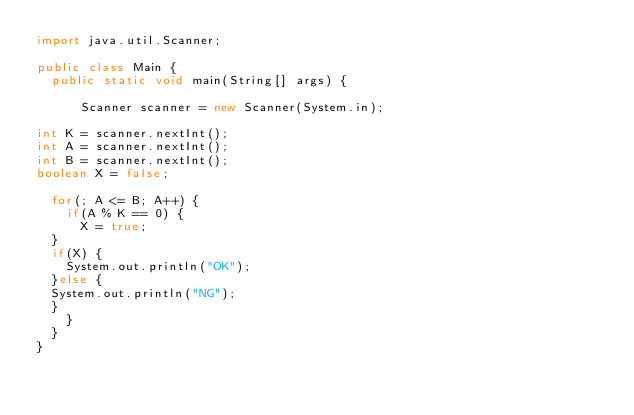Convert code to text. <code><loc_0><loc_0><loc_500><loc_500><_Java_>import java.util.Scanner;

public class Main {
	public static void main(String[] args) {

		  Scanner scanner = new Scanner(System.in);

int K = scanner.nextInt();
int A = scanner.nextInt();
int B = scanner.nextInt();
boolean X = false;

	for(; A <= B; A++) {
    if(A % K == 0) {
    	X = true;
	}
	if(X) {
    System.out.println("OK");
	}else {
	System.out.println("NG");
	}
	  }
	}
}</code> 